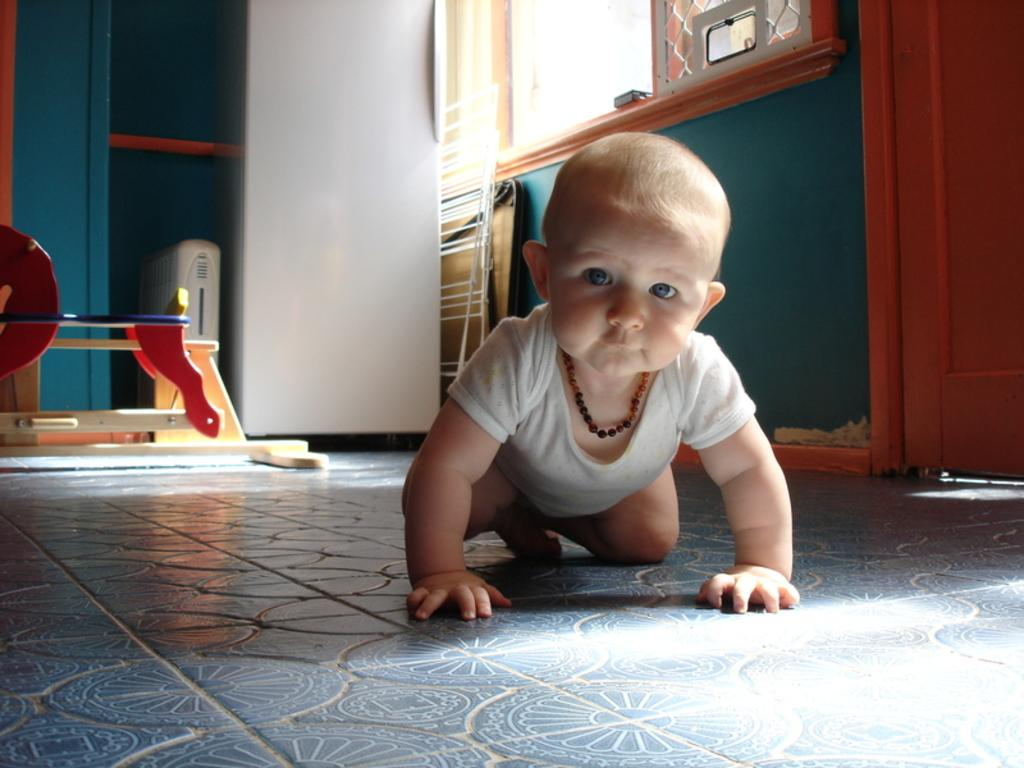What is the main subject of the image? There is a baby in the image. What is the baby doing in the image? The baby is crawling on the floor. What can be seen in the background of the image? There is a wall, windows, and other objects visible in the background of the image. What type of crown is the baby wearing in the image? There is no crown present in the image; the baby is not wearing any headgear. What role does the baby play in society in the image? The image does not depict any societal roles or context; it simply shows a baby crawling on the floor. 